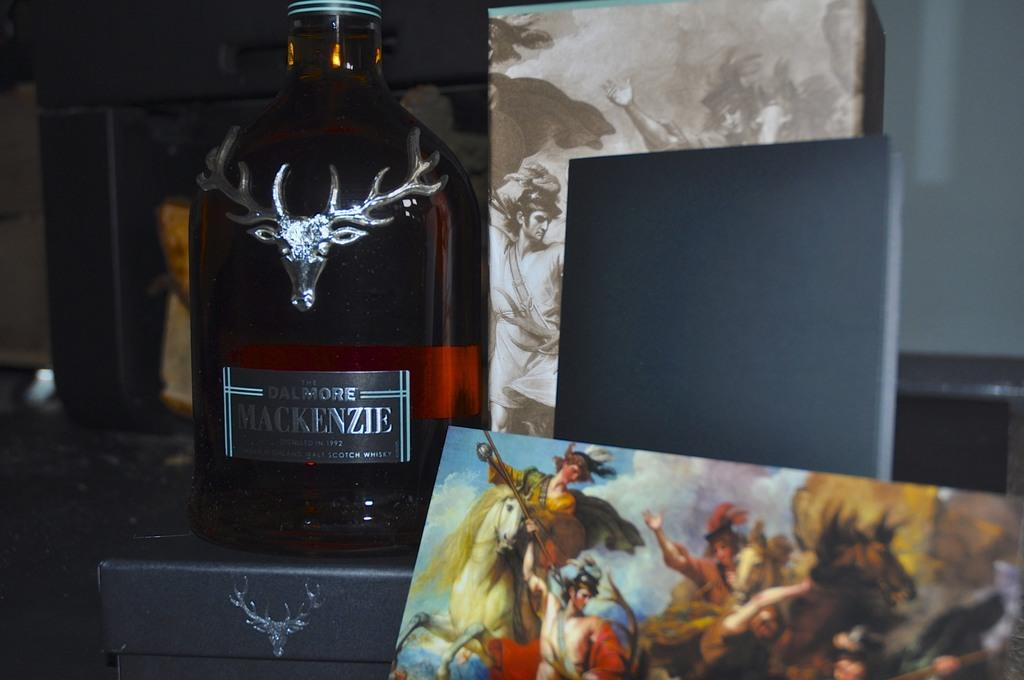<image>
Render a clear and concise summary of the photo. Bottle of The Dalmore Mackenzie from 1992 on display. 